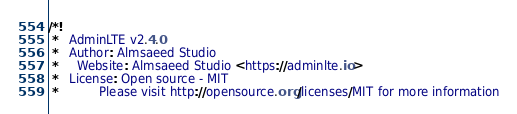Convert code to text. <code><loc_0><loc_0><loc_500><loc_500><_CSS_>/*!
 *   AdminLTE v2.4.0
 *   Author: Almsaeed Studio
 *	 Website: Almsaeed Studio <https://adminlte.io>
 *   License: Open source - MIT
 *           Please visit http://opensource.org/licenses/MIT for more information</code> 